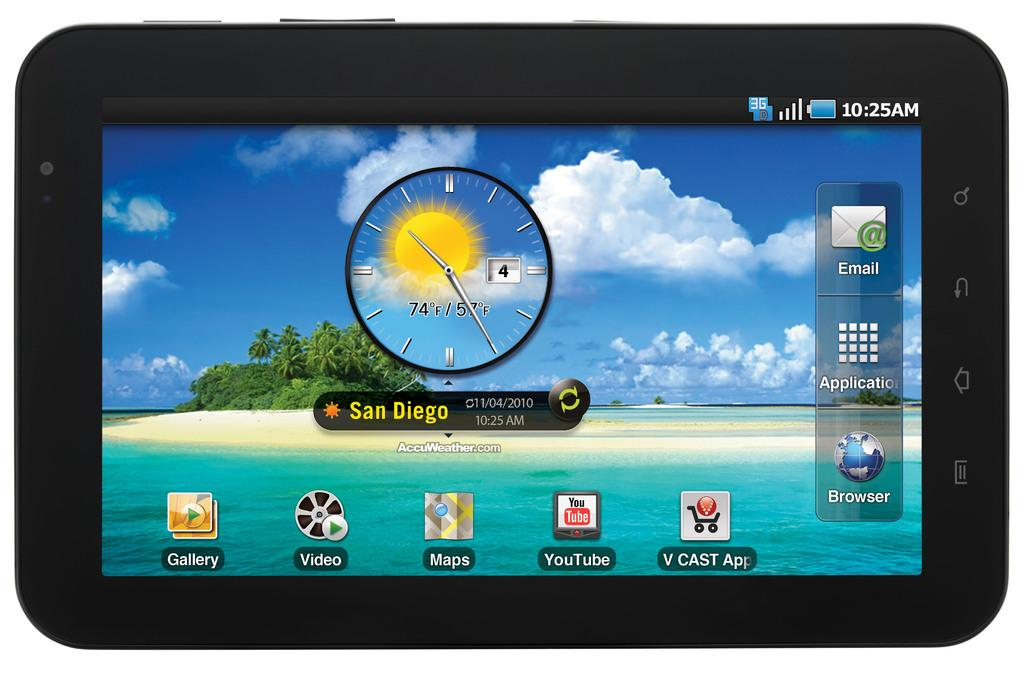<image>
Summarize the visual content of the image. A tablet is on the home screen and the weather widget says San Diego. 